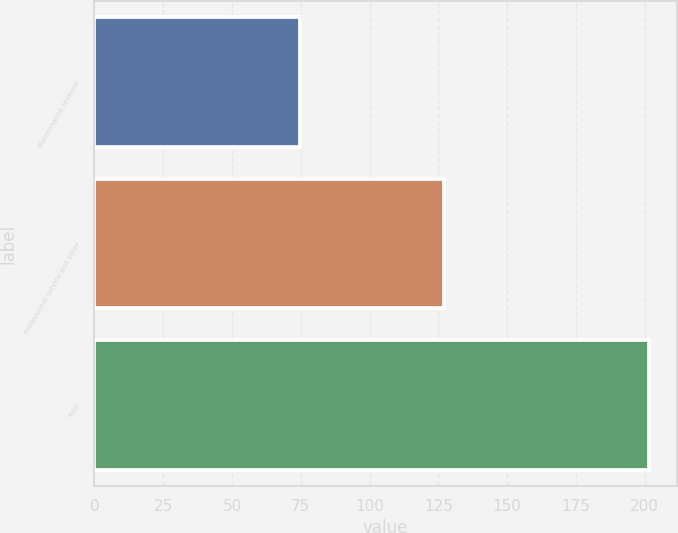Convert chart. <chart><loc_0><loc_0><loc_500><loc_500><bar_chart><fcel>Maintenance revenue<fcel>Professional service and other<fcel>Total<nl><fcel>74.6<fcel>127<fcel>201.6<nl></chart> 